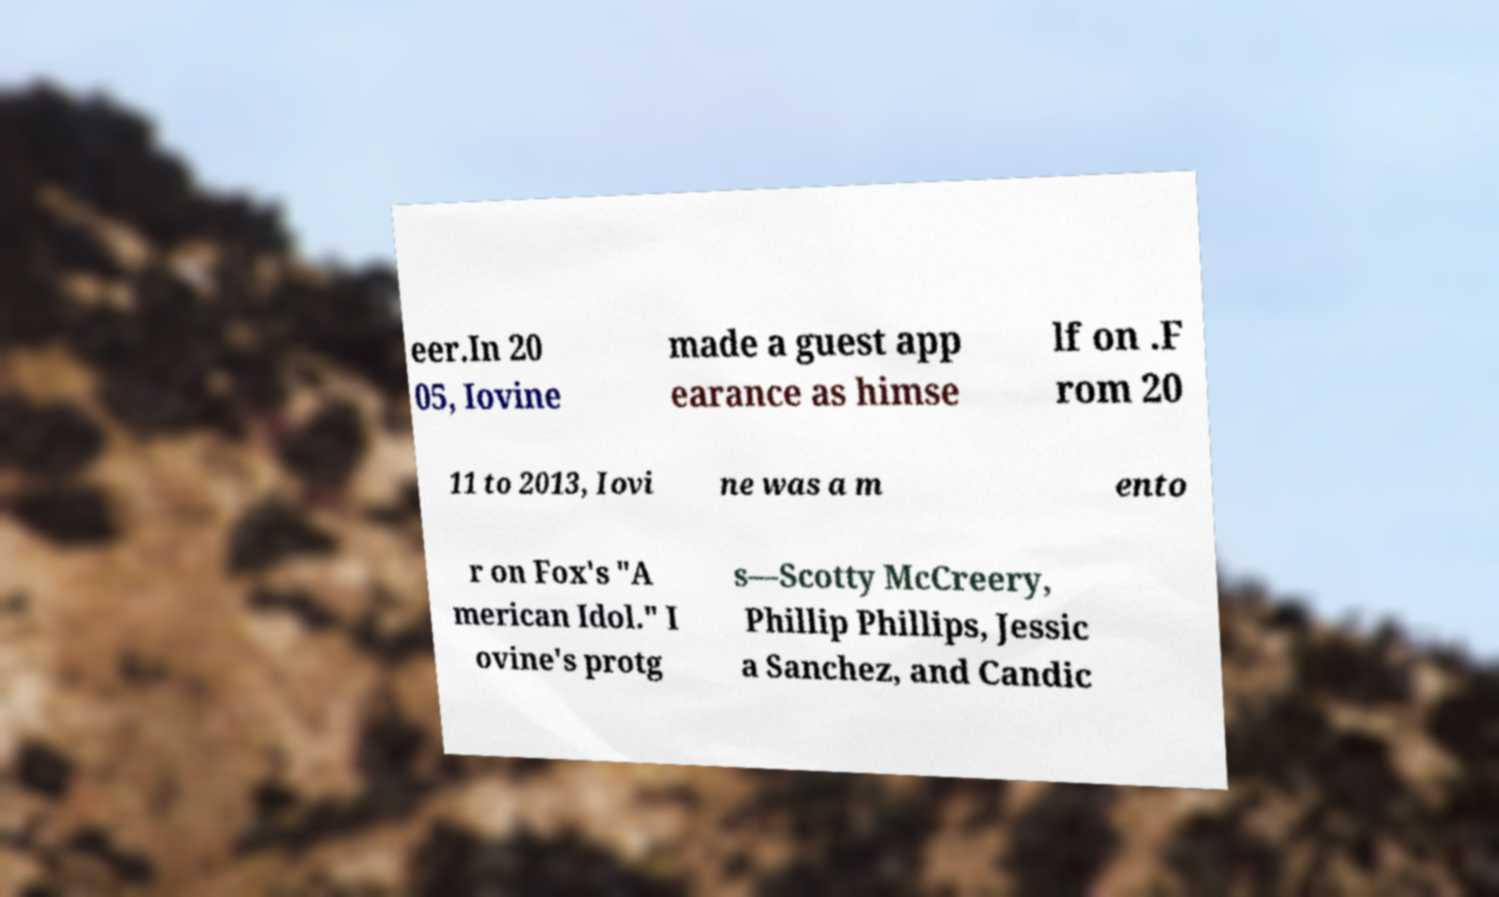I need the written content from this picture converted into text. Can you do that? eer.In 20 05, Iovine made a guest app earance as himse lf on .F rom 20 11 to 2013, Iovi ne was a m ento r on Fox's "A merican Idol." I ovine's protg s—Scotty McCreery, Phillip Phillips, Jessic a Sanchez, and Candic 